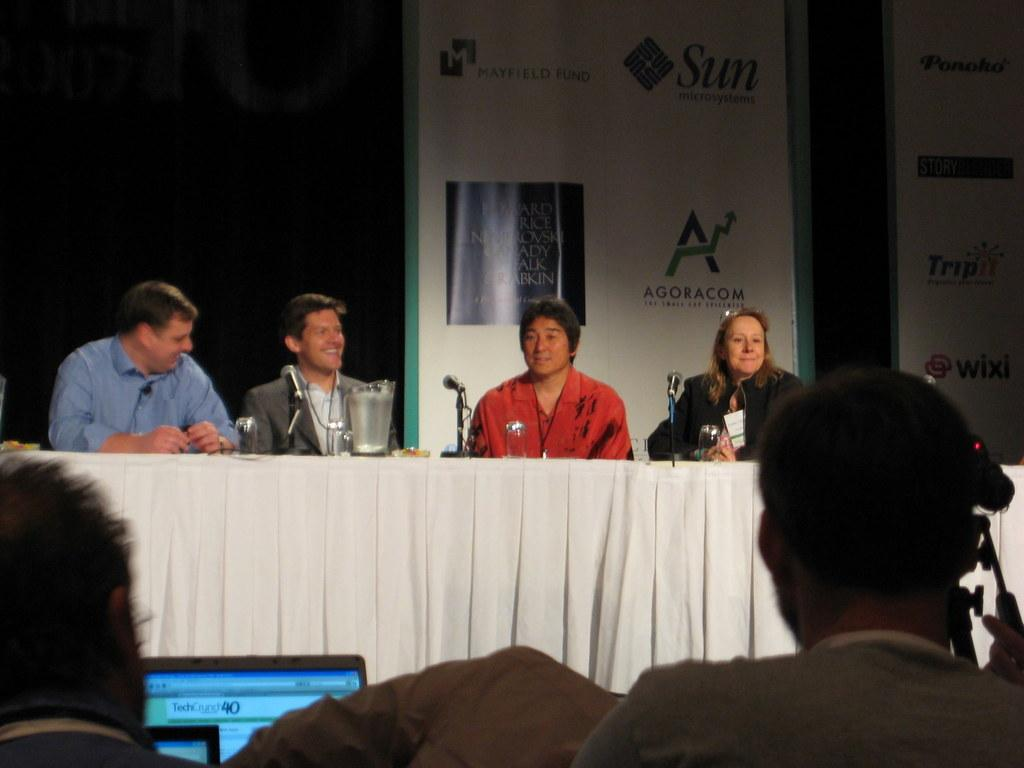What is the position of the people in the image? There is a group of people seated in the image. What are the people seated on? The people are seated on chairs. What objects are in front of the seated people? There are microphones in front of the seated people. Who is observing the seated people? There is an audience watching the seated people. What can be seen behind the seated people? There is a banner visible behind the seated people. What type of curtain is hanging behind the seated people in the image? There is no curtain visible in the image; only a banner can be seen behind the seated people. 